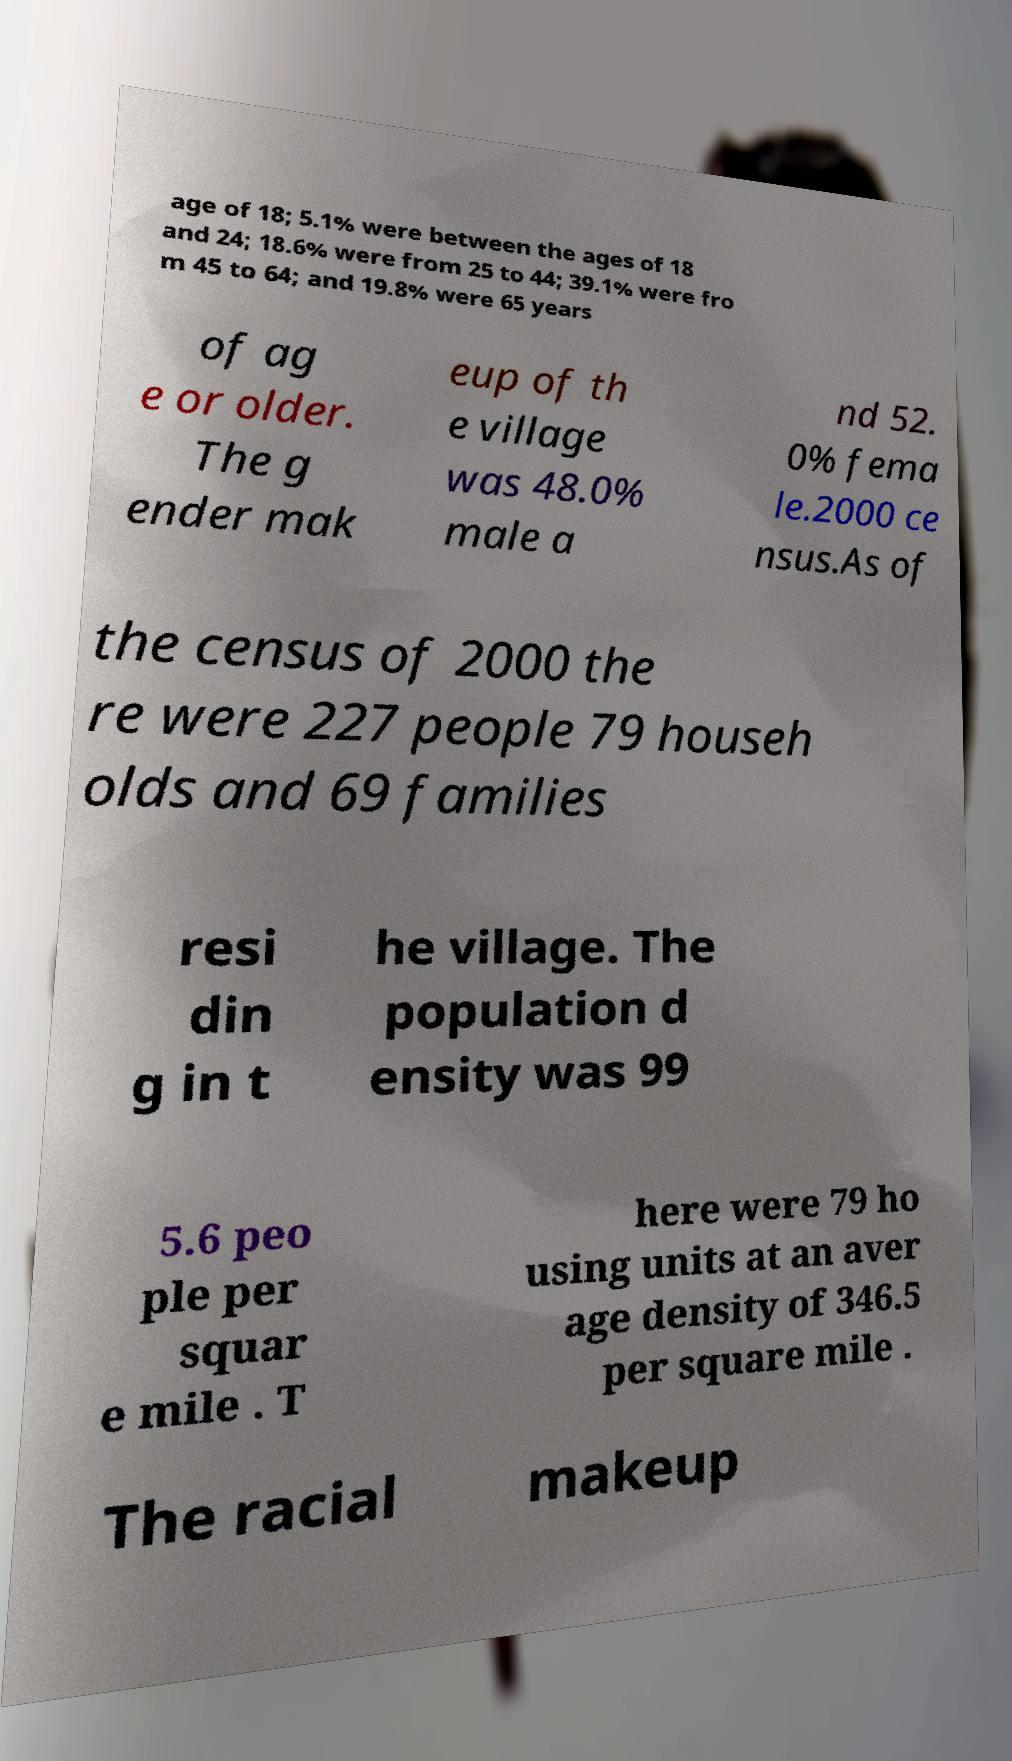For documentation purposes, I need the text within this image transcribed. Could you provide that? age of 18; 5.1% were between the ages of 18 and 24; 18.6% were from 25 to 44; 39.1% were fro m 45 to 64; and 19.8% were 65 years of ag e or older. The g ender mak eup of th e village was 48.0% male a nd 52. 0% fema le.2000 ce nsus.As of the census of 2000 the re were 227 people 79 househ olds and 69 families resi din g in t he village. The population d ensity was 99 5.6 peo ple per squar e mile . T here were 79 ho using units at an aver age density of 346.5 per square mile . The racial makeup 